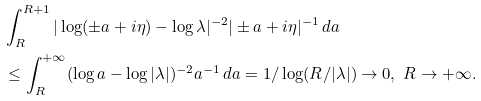Convert formula to latex. <formula><loc_0><loc_0><loc_500><loc_500>& \int _ { R } ^ { R + 1 } { | \log ( \pm a + i \eta ) - \log \lambda | ^ { - 2 } | \pm a + i \eta | ^ { - 1 } } \, { d a } \\ & \leq \int _ { R } ^ { + \infty } ( \log a - \log | \lambda | ) ^ { - 2 } a ^ { - 1 } \, d a = 1 / \log ( R / | \lambda | ) \to 0 , \ R \to + \infty .</formula> 